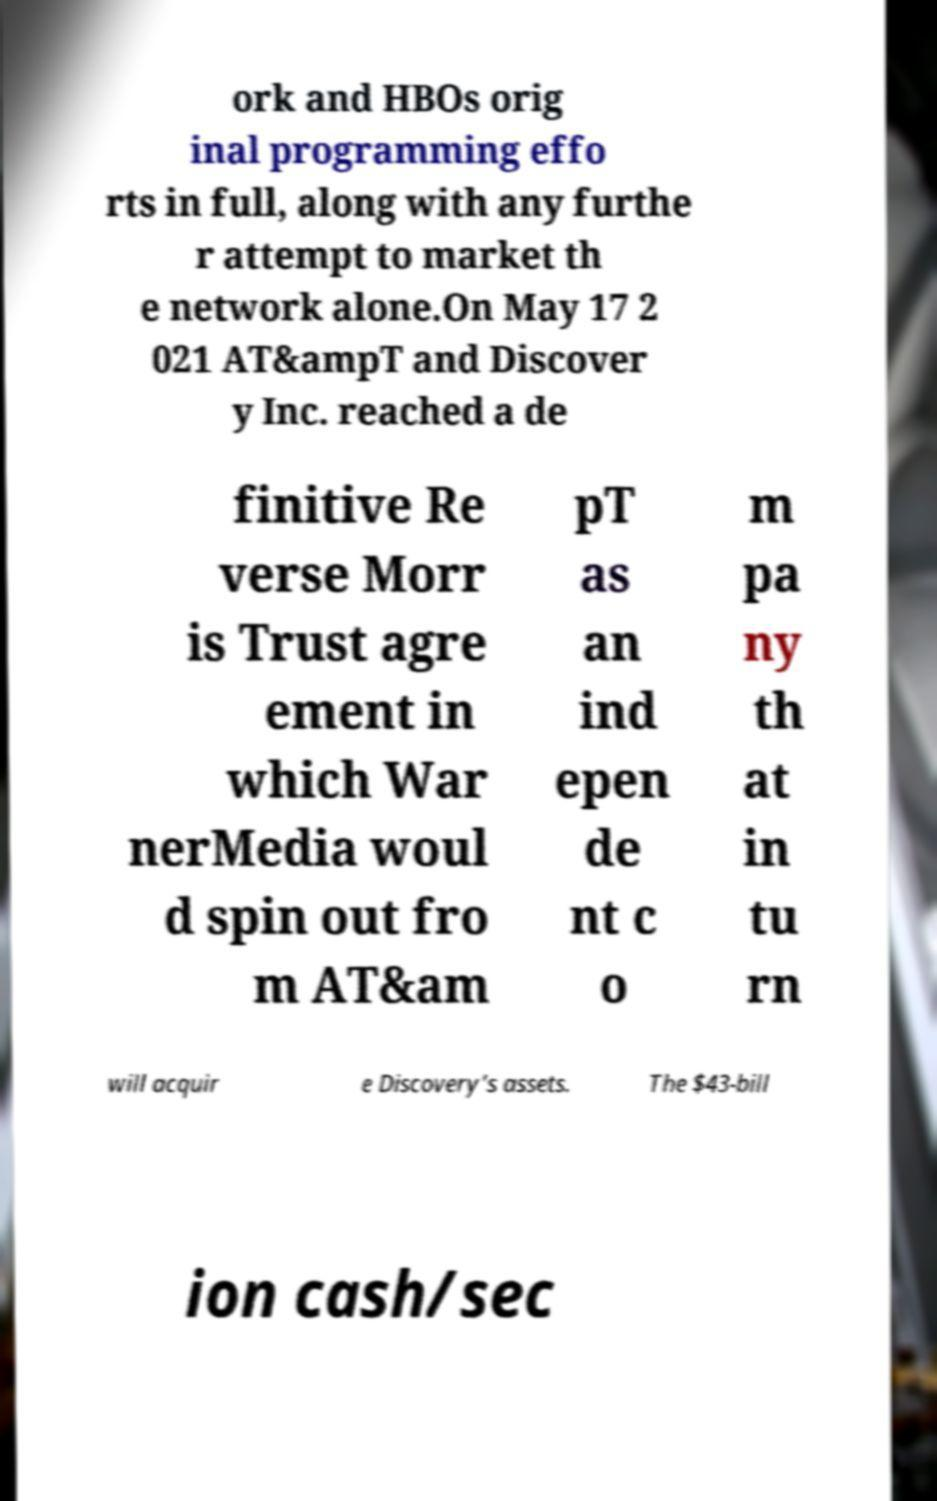Please identify and transcribe the text found in this image. ork and HBOs orig inal programming effo rts in full, along with any furthe r attempt to market th e network alone.On May 17 2 021 AT&ampT and Discover y Inc. reached a de finitive Re verse Morr is Trust agre ement in which War nerMedia woul d spin out fro m AT&am pT as an ind epen de nt c o m pa ny th at in tu rn will acquir e Discovery’s assets. The $43-bill ion cash/sec 